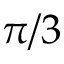Convert formula to latex. <formula><loc_0><loc_0><loc_500><loc_500>\pi / 3</formula> 